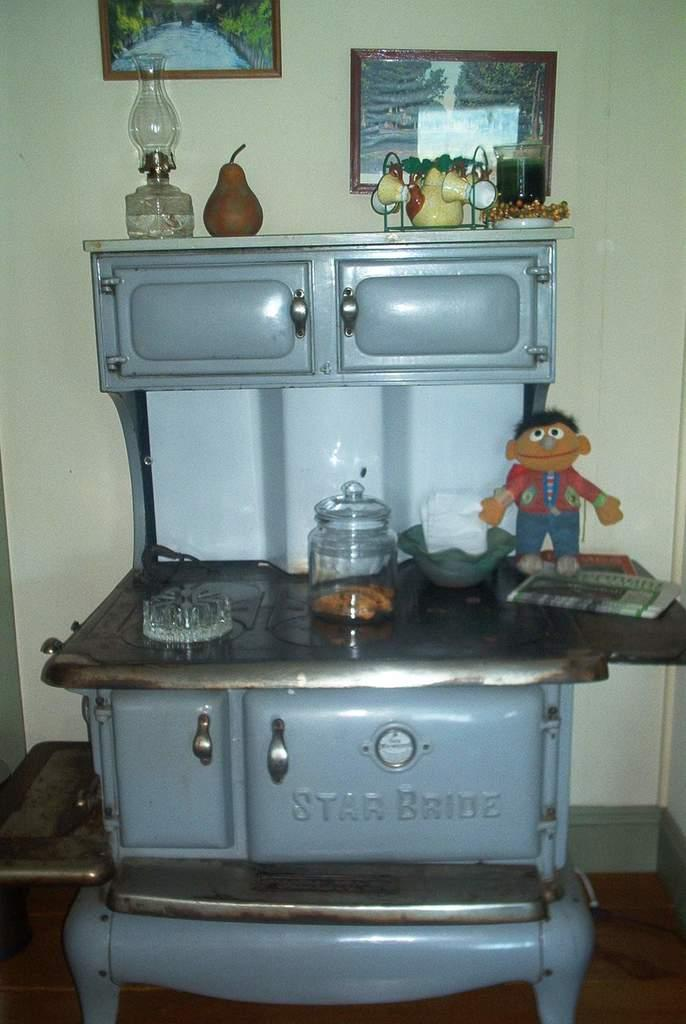<image>
Create a compact narrative representing the image presented. A vintage Star Bride stove with a toy Ernie on top of it. 